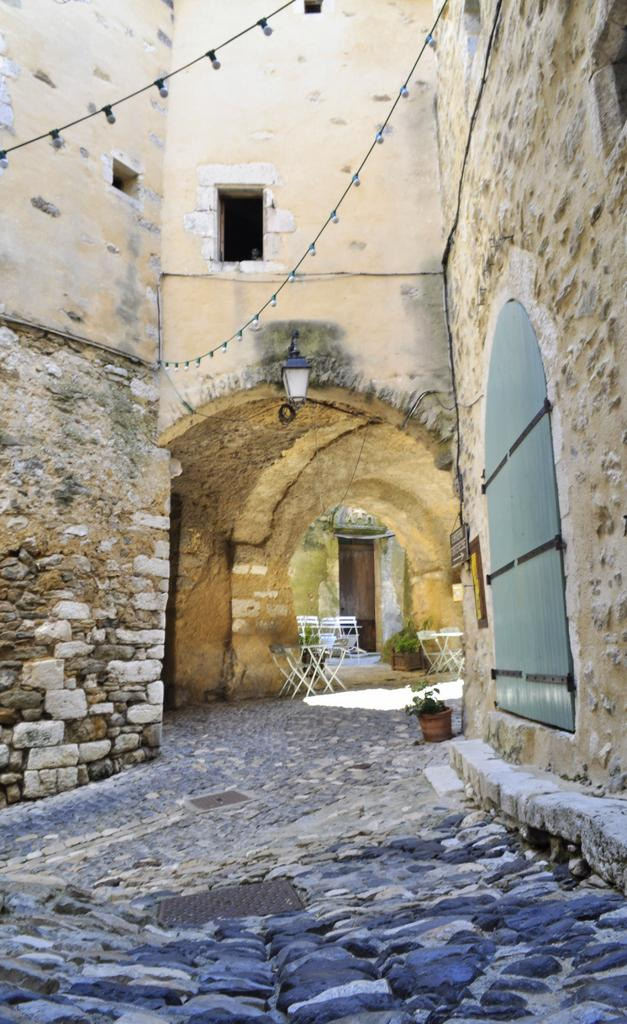What type of structure can be seen in the image? There is an arch in the image, which is a type of structure. What else can be seen in the image besides the arch? There are walls, electric lights, a street light, chairs, stones, and a houseplant visible in the image. How are the walls constructed in the image? The walls are built with cobblestones. What type of material is used for the electric lights in the image? The electric lights are hanged from a rope in the image. What type of linen is draped over the structure in the image? There is no linen draped over any structure in the image. What nation is represented by the structure in the image? The image does not represent any specific nation; it is a generic structure. 